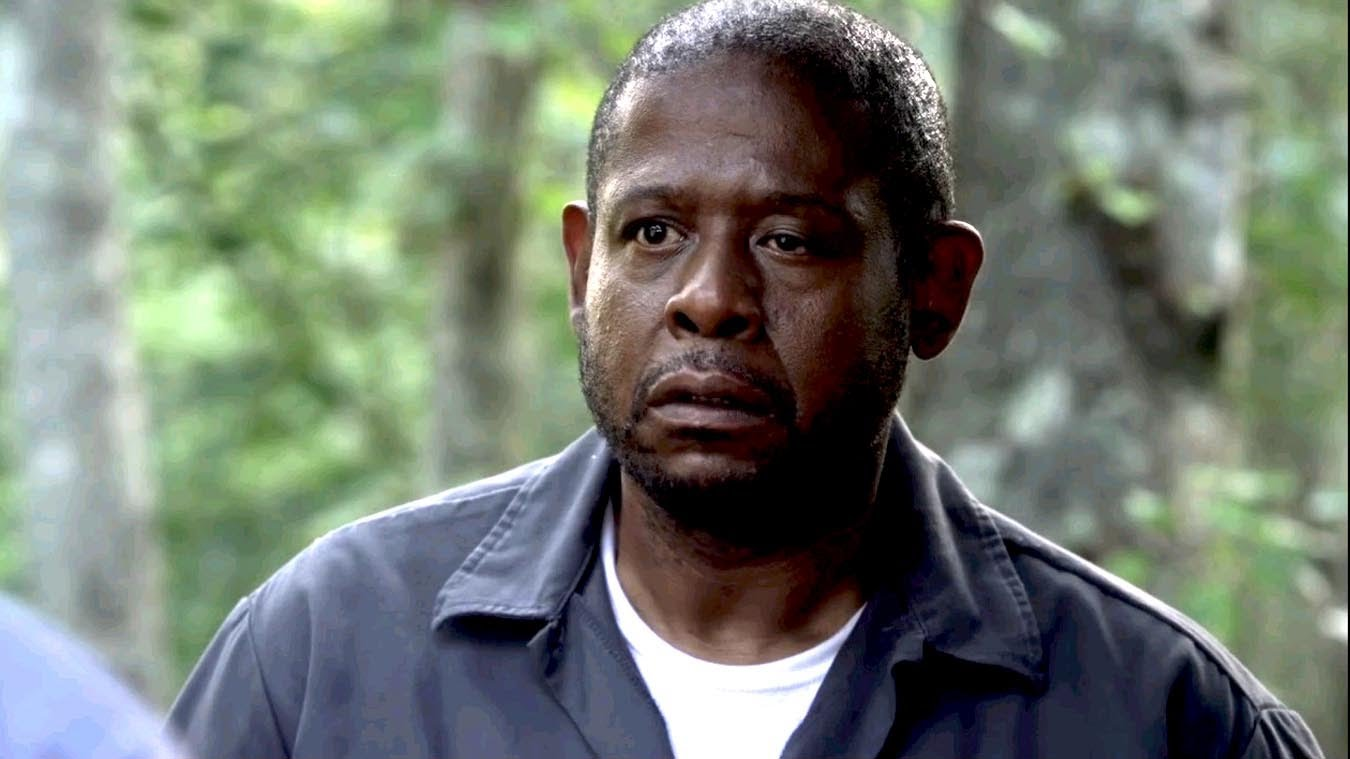What is this photo about? This image captures a poignant moment featuring an actor, set against the backdrop of a lush forest. The blurred greenery surrounding him adds a touch of tranquility and isolation, emphasizing his contemplative and slightly anxious expression. Dressed in a casual yet rugged outfit, he seems to be deeply absorbed in thought, or possibly observing an unseen object or situation off-camera. His intense focus and the serene yet slightly foreboding forest setting might suggest this is a still from a film or television series, where he portrays a character dealing with complex emotions or a tense scenario. 